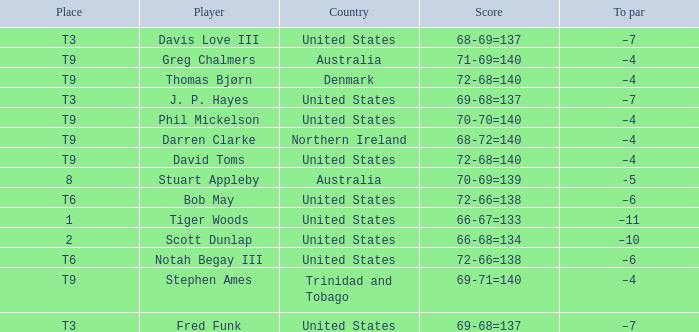What place had a To par of –10? 2.0. 